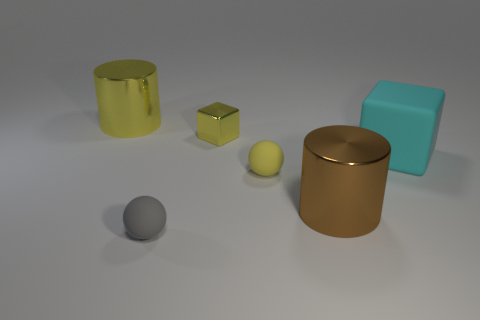What number of cylinders are there?
Your answer should be very brief. 2. There is a large shiny object on the right side of the cylinder that is behind the big brown cylinder; what shape is it?
Your response must be concise. Cylinder. How many shiny cylinders are in front of the small metal object?
Your answer should be very brief. 1. Does the small block have the same material as the cylinder that is to the right of the yellow rubber object?
Offer a terse response. Yes. Are there any yellow metallic cylinders of the same size as the gray sphere?
Your answer should be very brief. No. Are there the same number of small objects that are left of the yellow metallic block and cyan metallic cubes?
Give a very brief answer. No. The yellow metal cylinder has what size?
Your answer should be very brief. Large. How many matte blocks are right of the yellow object on the right side of the yellow shiny block?
Provide a succinct answer. 1. What shape is the rubber object that is left of the brown object and behind the gray object?
Provide a succinct answer. Sphere. How many shiny objects are the same color as the metal block?
Your response must be concise. 1. 